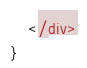<code> <loc_0><loc_0><loc_500><loc_500><_JavaScript_>    </div>
}</code> 